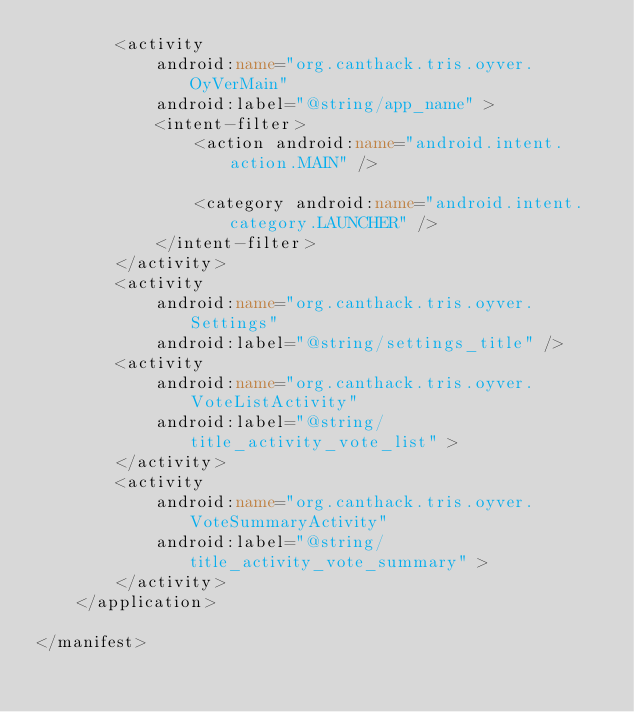Convert code to text. <code><loc_0><loc_0><loc_500><loc_500><_XML_>        <activity
            android:name="org.canthack.tris.oyver.OyVerMain"
            android:label="@string/app_name" >
            <intent-filter>
                <action android:name="android.intent.action.MAIN" />

                <category android:name="android.intent.category.LAUNCHER" />
            </intent-filter>
        </activity>
        <activity
            android:name="org.canthack.tris.oyver.Settings"
            android:label="@string/settings_title" />
        <activity
            android:name="org.canthack.tris.oyver.VoteListActivity"
            android:label="@string/title_activity_vote_list" >
        </activity>
        <activity
            android:name="org.canthack.tris.oyver.VoteSummaryActivity"
            android:label="@string/title_activity_vote_summary" >
        </activity>
    </application>

</manifest></code> 